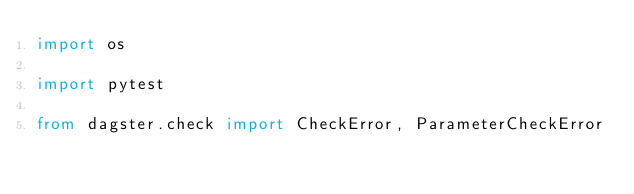Convert code to text. <code><loc_0><loc_0><loc_500><loc_500><_Python_>import os

import pytest

from dagster.check import CheckError, ParameterCheckError</code> 